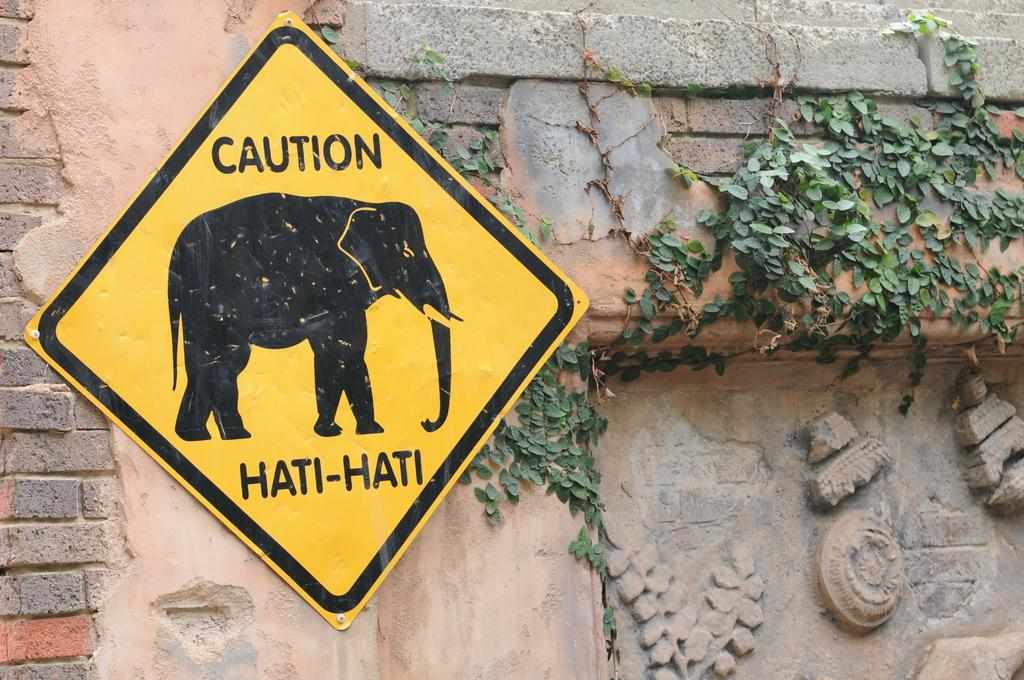What is the color of the board in the image? The board in the image is yellow. What image is on the board? The board has an image of an elephant. Where is the board located in the image? The board is attached to a wall. What type of vegetation is present in the image? There is a small plant in the image. What is the color of the plant? The plant is green in color. What type of cap is the brother wearing in the image? There is no brother or cap present in the image. How is the knife being used in the image? There is no knife present in the image. 